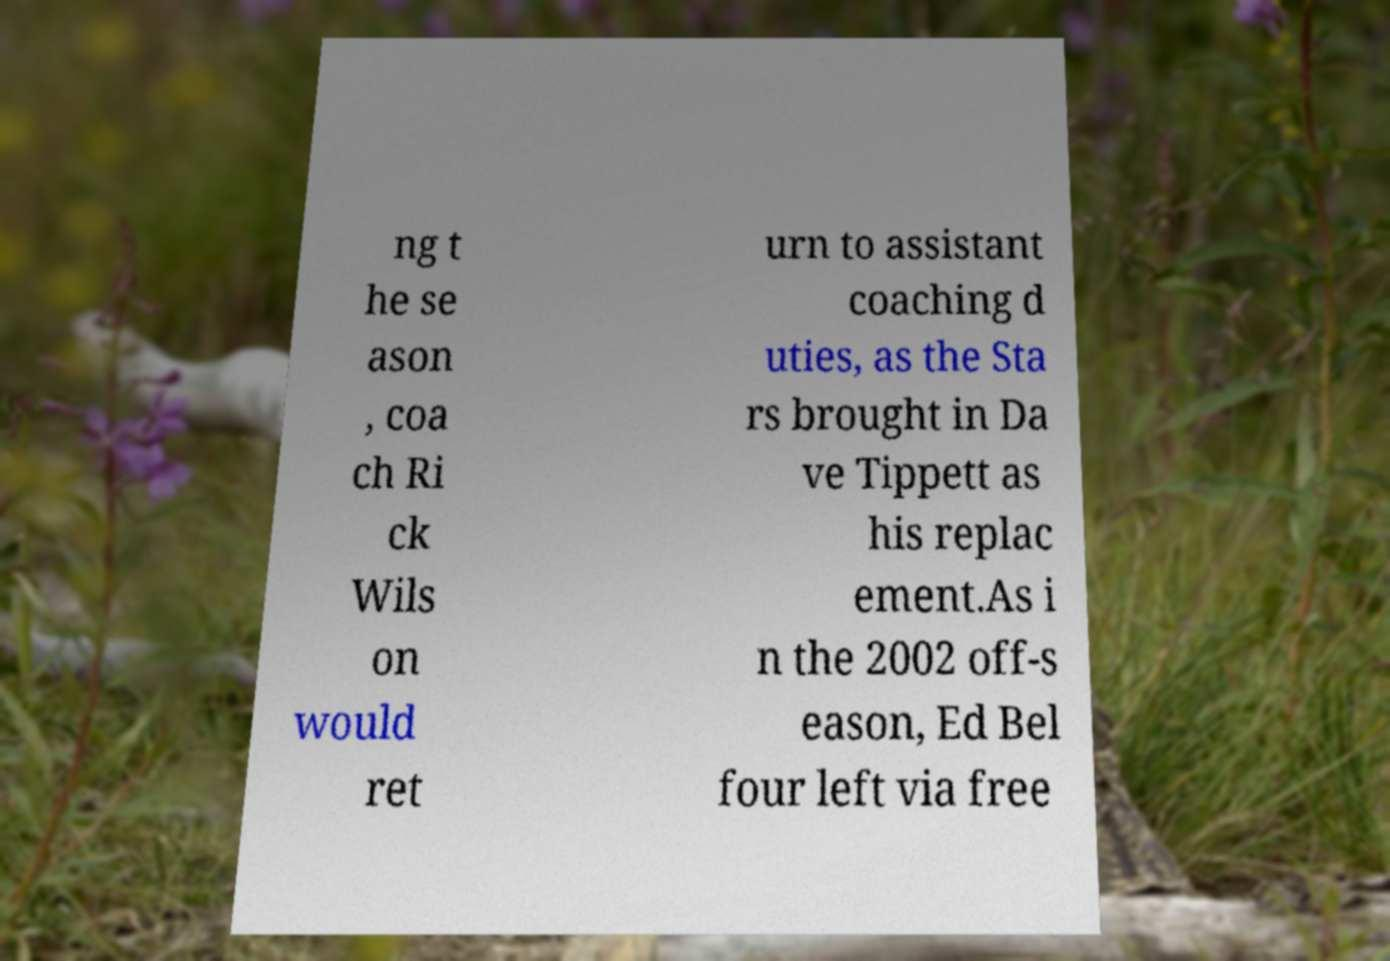Can you accurately transcribe the text from the provided image for me? ng t he se ason , coa ch Ri ck Wils on would ret urn to assistant coaching d uties, as the Sta rs brought in Da ve Tippett as his replac ement.As i n the 2002 off-s eason, Ed Bel four left via free 